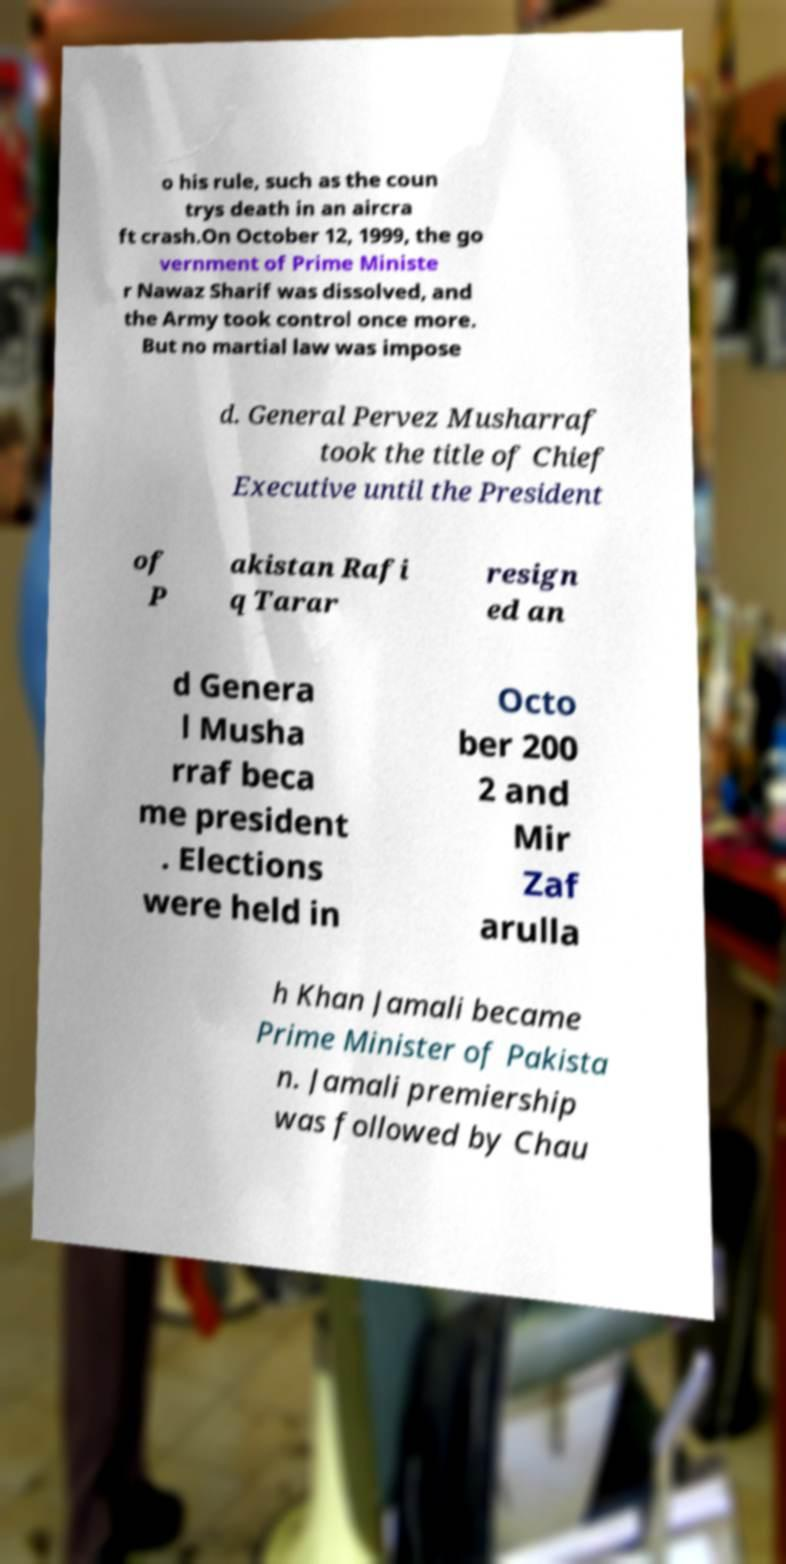Please identify and transcribe the text found in this image. o his rule, such as the coun trys death in an aircra ft crash.On October 12, 1999, the go vernment of Prime Ministe r Nawaz Sharif was dissolved, and the Army took control once more. But no martial law was impose d. General Pervez Musharraf took the title of Chief Executive until the President of P akistan Rafi q Tarar resign ed an d Genera l Musha rraf beca me president . Elections were held in Octo ber 200 2 and Mir Zaf arulla h Khan Jamali became Prime Minister of Pakista n. Jamali premiership was followed by Chau 